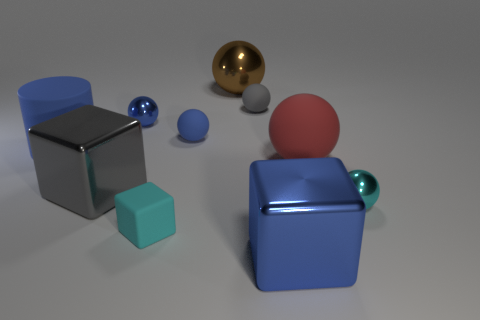How many other objects are there of the same material as the big brown sphere?
Ensure brevity in your answer.  4. Is there any other thing that is the same size as the cyan metallic thing?
Give a very brief answer. Yes. Is the number of small cyan things greater than the number of large gray metallic things?
Offer a terse response. Yes. There is a blue matte object that is behind the large blue thing that is behind the cube right of the blue rubber sphere; what size is it?
Your answer should be very brief. Small. Do the cyan shiny object and the blue metal object that is on the right side of the tiny gray matte ball have the same size?
Provide a succinct answer. No. Are there fewer cyan metal spheres behind the large red matte sphere than cylinders?
Ensure brevity in your answer.  Yes. What number of big rubber spheres have the same color as the small matte cube?
Ensure brevity in your answer.  0. Is the number of small cyan cubes less than the number of large green cylinders?
Your answer should be very brief. No. Do the large cylinder and the big brown thing have the same material?
Ensure brevity in your answer.  No. What number of other objects are the same size as the cyan metal thing?
Provide a short and direct response. 4. 